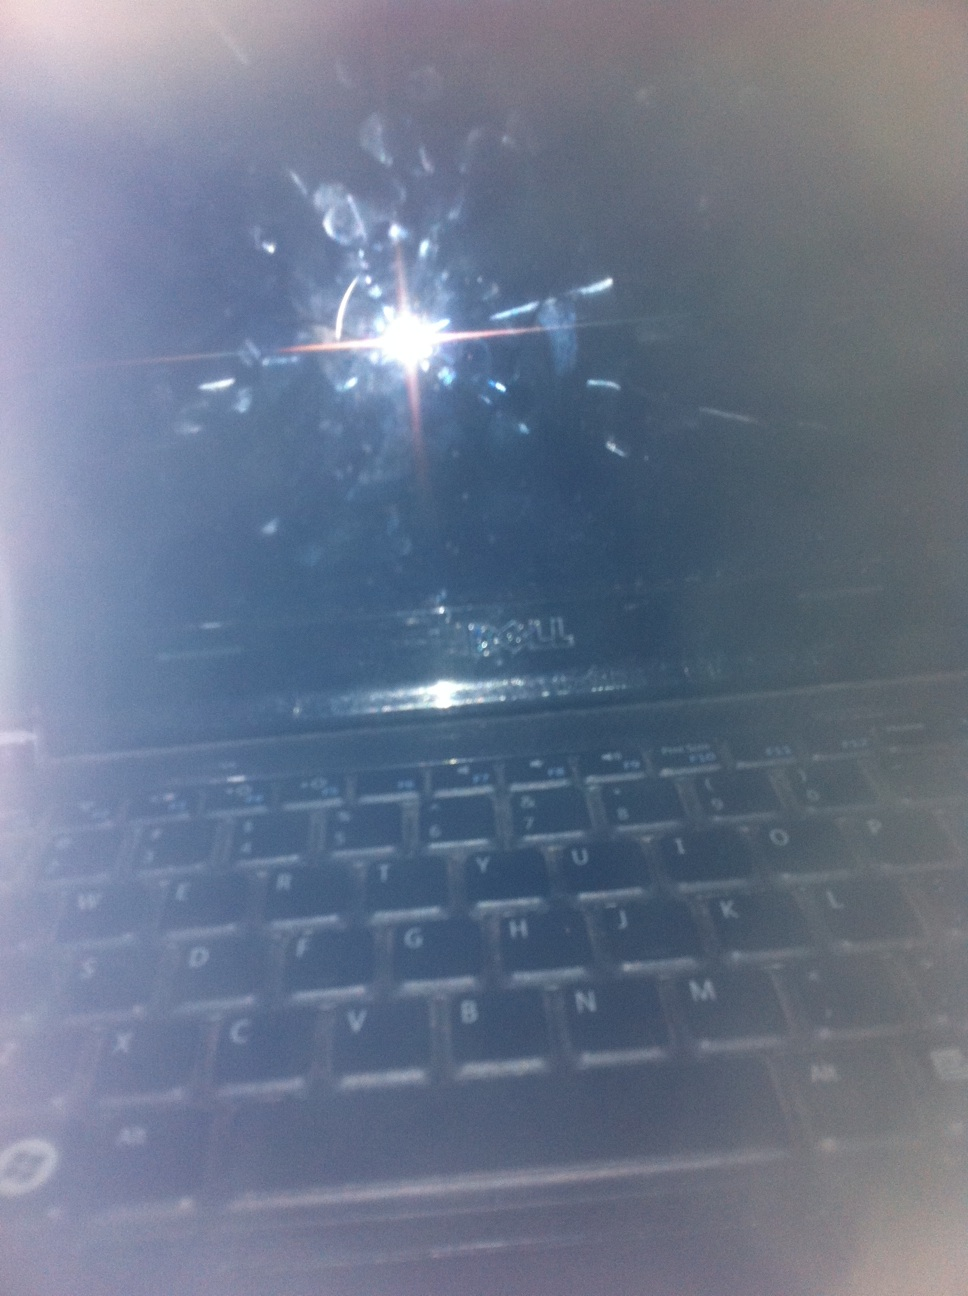What can you infer about the state of the laptop from this image? The laptop seems to be turned off or in a sleep mode because the screen is dark and there's no active display. Additionally, the screen has many fingerprints and smudges, indicating frequent use without recent cleaning. Why do you think the screen has so many smudges? The numerous smudges and fingerprints on the screen suggest that this laptop is frequently used, possibly by multiple people or by someone who often touches the screen. Fingerprints can accumulate quickly, especially if the user interacts with the screen to show things to others or due to regular use. 